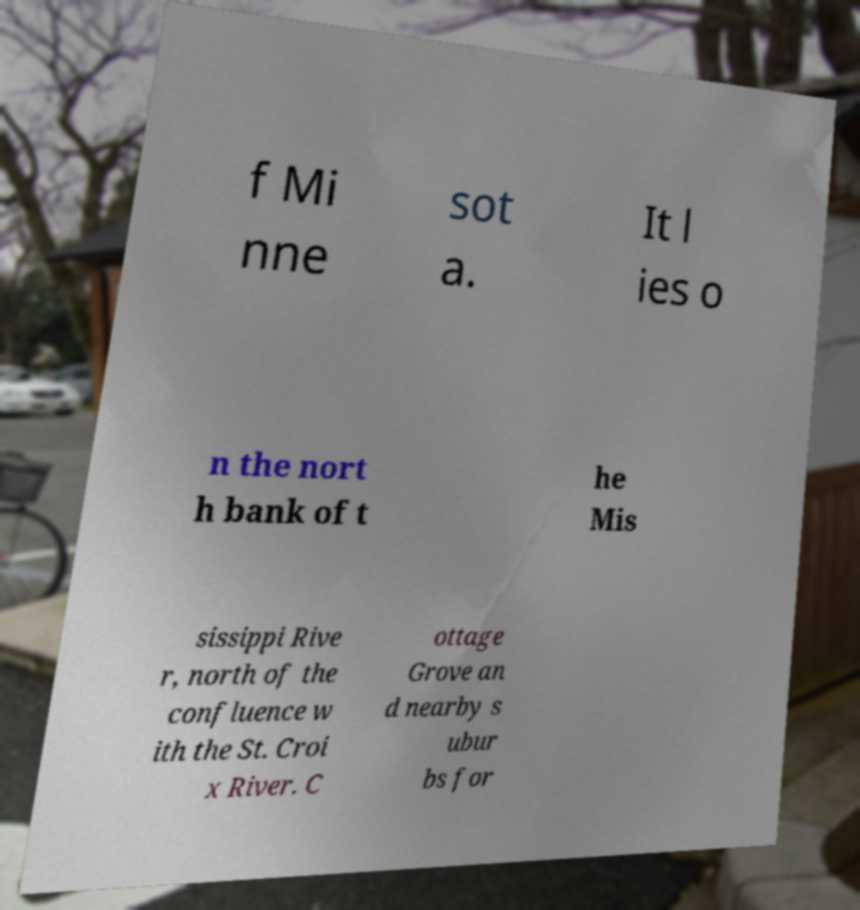Could you assist in decoding the text presented in this image and type it out clearly? f Mi nne sot a. It l ies o n the nort h bank of t he Mis sissippi Rive r, north of the confluence w ith the St. Croi x River. C ottage Grove an d nearby s ubur bs for 